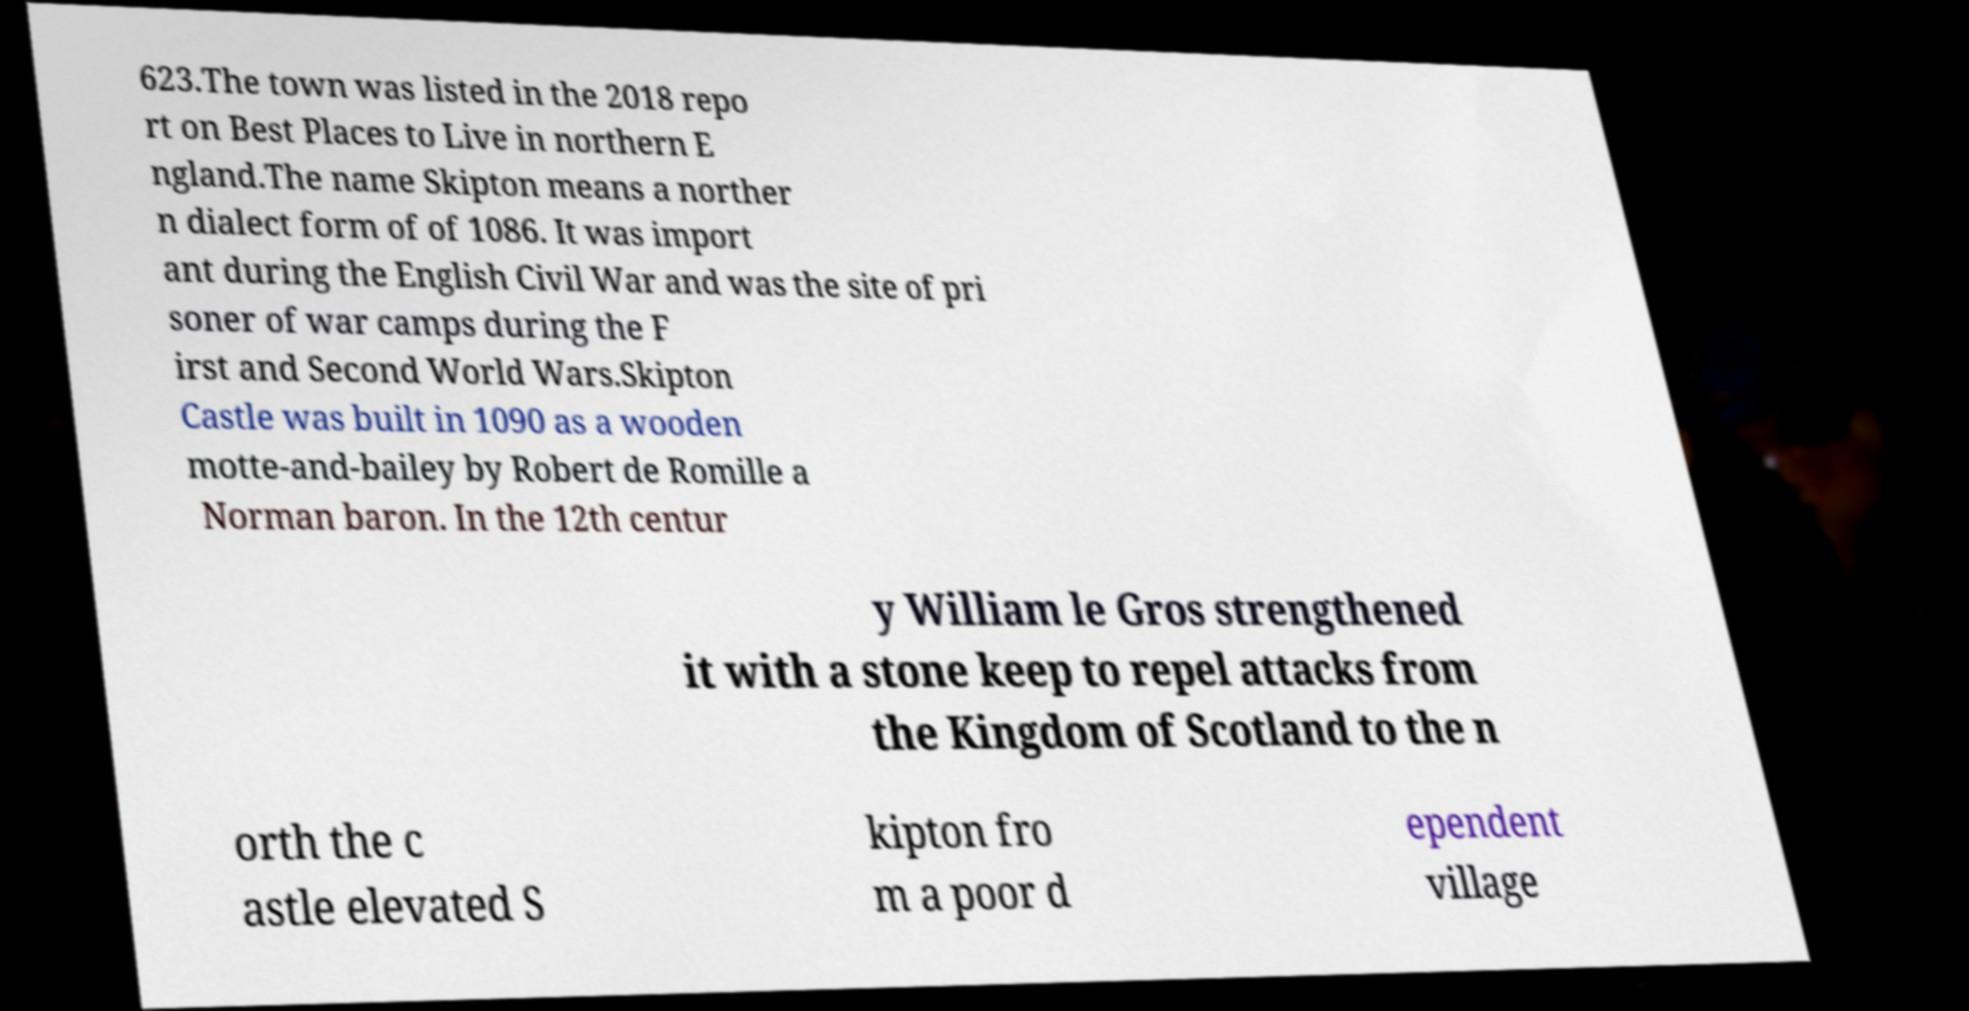Please identify and transcribe the text found in this image. 623.The town was listed in the 2018 repo rt on Best Places to Live in northern E ngland.The name Skipton means a norther n dialect form of of 1086. It was import ant during the English Civil War and was the site of pri soner of war camps during the F irst and Second World Wars.Skipton Castle was built in 1090 as a wooden motte-and-bailey by Robert de Romille a Norman baron. In the 12th centur y William le Gros strengthened it with a stone keep to repel attacks from the Kingdom of Scotland to the n orth the c astle elevated S kipton fro m a poor d ependent village 